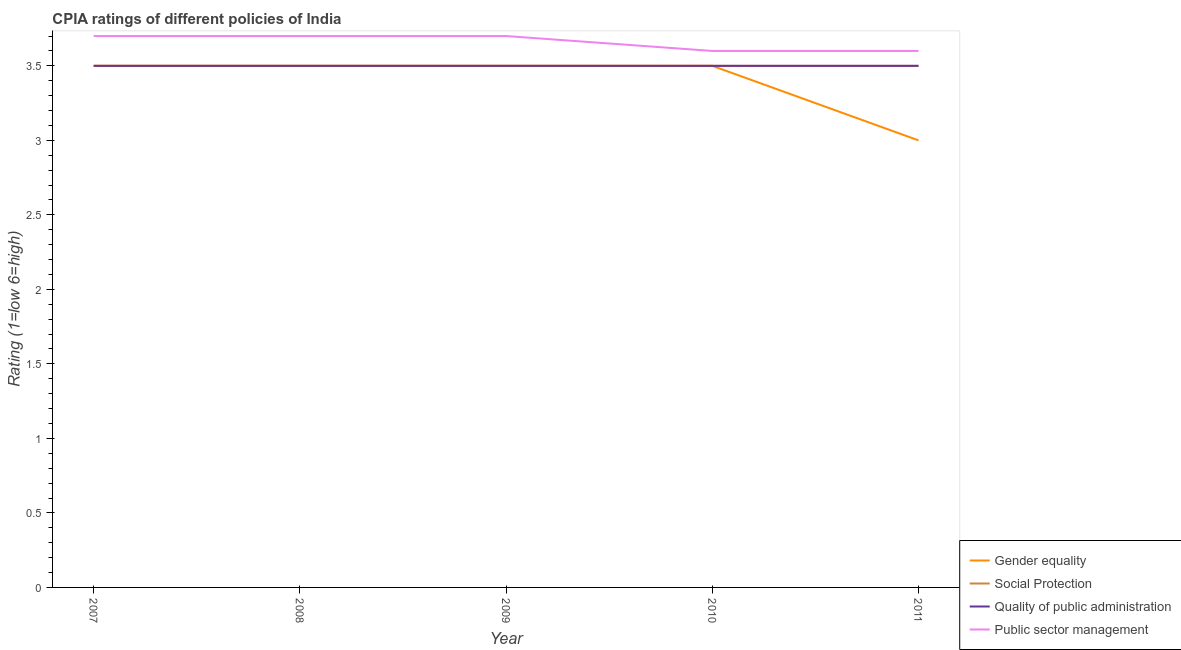Is the number of lines equal to the number of legend labels?
Keep it short and to the point. Yes. Across all years, what is the maximum cpia rating of public sector management?
Keep it short and to the point. 3.7. In which year was the cpia rating of social protection maximum?
Your answer should be very brief. 2007. What is the difference between the cpia rating of public sector management in 2007 and the cpia rating of quality of public administration in 2008?
Offer a very short reply. 0.2. In the year 2011, what is the difference between the cpia rating of gender equality and cpia rating of social protection?
Provide a succinct answer. -0.5. In how many years, is the cpia rating of quality of public administration greater than 2.2?
Your response must be concise. 5. What is the ratio of the cpia rating of quality of public administration in 2007 to that in 2011?
Your answer should be very brief. 1. What is the difference between the highest and the second highest cpia rating of public sector management?
Keep it short and to the point. 0. Does the cpia rating of gender equality monotonically increase over the years?
Make the answer very short. No. Is the cpia rating of gender equality strictly less than the cpia rating of social protection over the years?
Ensure brevity in your answer.  No. How many lines are there?
Make the answer very short. 4. How many years are there in the graph?
Make the answer very short. 5. What is the difference between two consecutive major ticks on the Y-axis?
Ensure brevity in your answer.  0.5. Does the graph contain any zero values?
Give a very brief answer. No. What is the title of the graph?
Your answer should be compact. CPIA ratings of different policies of India. What is the label or title of the Y-axis?
Your answer should be compact. Rating (1=low 6=high). What is the Rating (1=low 6=high) of Social Protection in 2007?
Keep it short and to the point. 3.5. What is the Rating (1=low 6=high) in Public sector management in 2007?
Ensure brevity in your answer.  3.7. What is the Rating (1=low 6=high) of Social Protection in 2008?
Give a very brief answer. 3.5. What is the Rating (1=low 6=high) of Quality of public administration in 2008?
Offer a very short reply. 3.5. What is the Rating (1=low 6=high) in Public sector management in 2008?
Your response must be concise. 3.7. What is the Rating (1=low 6=high) of Gender equality in 2009?
Provide a succinct answer. 3.5. What is the Rating (1=low 6=high) of Social Protection in 2009?
Your answer should be compact. 3.5. What is the Rating (1=low 6=high) in Public sector management in 2009?
Your response must be concise. 3.7. What is the Rating (1=low 6=high) of Gender equality in 2010?
Give a very brief answer. 3.5. What is the Rating (1=low 6=high) of Quality of public administration in 2010?
Offer a terse response. 3.5. What is the Rating (1=low 6=high) in Gender equality in 2011?
Keep it short and to the point. 3. What is the Rating (1=low 6=high) in Social Protection in 2011?
Offer a terse response. 3.5. What is the Rating (1=low 6=high) in Public sector management in 2011?
Ensure brevity in your answer.  3.6. Across all years, what is the maximum Rating (1=low 6=high) in Gender equality?
Offer a terse response. 3.5. Across all years, what is the maximum Rating (1=low 6=high) in Social Protection?
Your answer should be very brief. 3.5. Across all years, what is the minimum Rating (1=low 6=high) of Gender equality?
Your response must be concise. 3. What is the total Rating (1=low 6=high) of Gender equality in the graph?
Make the answer very short. 17. What is the difference between the Rating (1=low 6=high) in Social Protection in 2007 and that in 2008?
Provide a succinct answer. 0. What is the difference between the Rating (1=low 6=high) in Quality of public administration in 2007 and that in 2008?
Offer a very short reply. 0. What is the difference between the Rating (1=low 6=high) of Public sector management in 2007 and that in 2008?
Make the answer very short. 0. What is the difference between the Rating (1=low 6=high) of Gender equality in 2007 and that in 2009?
Provide a short and direct response. 0. What is the difference between the Rating (1=low 6=high) in Quality of public administration in 2007 and that in 2010?
Offer a terse response. 0. What is the difference between the Rating (1=low 6=high) of Gender equality in 2007 and that in 2011?
Provide a succinct answer. 0.5. What is the difference between the Rating (1=low 6=high) of Quality of public administration in 2007 and that in 2011?
Your response must be concise. 0. What is the difference between the Rating (1=low 6=high) in Public sector management in 2007 and that in 2011?
Your response must be concise. 0.1. What is the difference between the Rating (1=low 6=high) in Gender equality in 2008 and that in 2010?
Provide a short and direct response. 0. What is the difference between the Rating (1=low 6=high) in Gender equality in 2008 and that in 2011?
Keep it short and to the point. 0.5. What is the difference between the Rating (1=low 6=high) of Social Protection in 2008 and that in 2011?
Provide a short and direct response. 0. What is the difference between the Rating (1=low 6=high) of Quality of public administration in 2008 and that in 2011?
Provide a succinct answer. 0. What is the difference between the Rating (1=low 6=high) in Public sector management in 2008 and that in 2011?
Your response must be concise. 0.1. What is the difference between the Rating (1=low 6=high) of Quality of public administration in 2009 and that in 2010?
Your answer should be compact. 0. What is the difference between the Rating (1=low 6=high) in Social Protection in 2009 and that in 2011?
Your response must be concise. 0. What is the difference between the Rating (1=low 6=high) of Public sector management in 2009 and that in 2011?
Ensure brevity in your answer.  0.1. What is the difference between the Rating (1=low 6=high) in Quality of public administration in 2010 and that in 2011?
Keep it short and to the point. 0. What is the difference between the Rating (1=low 6=high) of Public sector management in 2010 and that in 2011?
Offer a terse response. 0. What is the difference between the Rating (1=low 6=high) of Gender equality in 2007 and the Rating (1=low 6=high) of Social Protection in 2008?
Your response must be concise. 0. What is the difference between the Rating (1=low 6=high) in Gender equality in 2007 and the Rating (1=low 6=high) in Public sector management in 2008?
Provide a short and direct response. -0.2. What is the difference between the Rating (1=low 6=high) in Social Protection in 2007 and the Rating (1=low 6=high) in Quality of public administration in 2008?
Keep it short and to the point. 0. What is the difference between the Rating (1=low 6=high) in Quality of public administration in 2007 and the Rating (1=low 6=high) in Public sector management in 2008?
Your answer should be compact. -0.2. What is the difference between the Rating (1=low 6=high) in Gender equality in 2007 and the Rating (1=low 6=high) in Quality of public administration in 2009?
Provide a succinct answer. 0. What is the difference between the Rating (1=low 6=high) of Social Protection in 2007 and the Rating (1=low 6=high) of Quality of public administration in 2009?
Your response must be concise. 0. What is the difference between the Rating (1=low 6=high) in Gender equality in 2007 and the Rating (1=low 6=high) in Quality of public administration in 2010?
Ensure brevity in your answer.  0. What is the difference between the Rating (1=low 6=high) in Social Protection in 2007 and the Rating (1=low 6=high) in Quality of public administration in 2010?
Provide a succinct answer. 0. What is the difference between the Rating (1=low 6=high) in Gender equality in 2007 and the Rating (1=low 6=high) in Quality of public administration in 2011?
Keep it short and to the point. 0. What is the difference between the Rating (1=low 6=high) in Gender equality in 2007 and the Rating (1=low 6=high) in Public sector management in 2011?
Provide a short and direct response. -0.1. What is the difference between the Rating (1=low 6=high) of Social Protection in 2007 and the Rating (1=low 6=high) of Quality of public administration in 2011?
Your response must be concise. 0. What is the difference between the Rating (1=low 6=high) of Gender equality in 2008 and the Rating (1=low 6=high) of Social Protection in 2009?
Keep it short and to the point. 0. What is the difference between the Rating (1=low 6=high) in Quality of public administration in 2008 and the Rating (1=low 6=high) in Public sector management in 2009?
Your answer should be compact. -0.2. What is the difference between the Rating (1=low 6=high) in Gender equality in 2008 and the Rating (1=low 6=high) in Social Protection in 2010?
Your answer should be very brief. 0. What is the difference between the Rating (1=low 6=high) in Gender equality in 2008 and the Rating (1=low 6=high) in Quality of public administration in 2010?
Your answer should be very brief. 0. What is the difference between the Rating (1=low 6=high) in Gender equality in 2008 and the Rating (1=low 6=high) in Public sector management in 2010?
Your answer should be very brief. -0.1. What is the difference between the Rating (1=low 6=high) of Quality of public administration in 2008 and the Rating (1=low 6=high) of Public sector management in 2010?
Your answer should be very brief. -0.1. What is the difference between the Rating (1=low 6=high) of Gender equality in 2008 and the Rating (1=low 6=high) of Quality of public administration in 2011?
Your answer should be compact. 0. What is the difference between the Rating (1=low 6=high) in Social Protection in 2008 and the Rating (1=low 6=high) in Quality of public administration in 2011?
Offer a very short reply. 0. What is the difference between the Rating (1=low 6=high) in Quality of public administration in 2008 and the Rating (1=low 6=high) in Public sector management in 2011?
Your answer should be compact. -0.1. What is the difference between the Rating (1=low 6=high) of Gender equality in 2009 and the Rating (1=low 6=high) of Social Protection in 2010?
Give a very brief answer. 0. What is the difference between the Rating (1=low 6=high) in Gender equality in 2009 and the Rating (1=low 6=high) in Quality of public administration in 2010?
Keep it short and to the point. 0. What is the difference between the Rating (1=low 6=high) of Gender equality in 2009 and the Rating (1=low 6=high) of Public sector management in 2010?
Make the answer very short. -0.1. What is the difference between the Rating (1=low 6=high) of Social Protection in 2009 and the Rating (1=low 6=high) of Quality of public administration in 2010?
Your response must be concise. 0. What is the difference between the Rating (1=low 6=high) of Quality of public administration in 2009 and the Rating (1=low 6=high) of Public sector management in 2010?
Your answer should be very brief. -0.1. What is the difference between the Rating (1=low 6=high) of Gender equality in 2009 and the Rating (1=low 6=high) of Social Protection in 2011?
Your answer should be compact. 0. What is the difference between the Rating (1=low 6=high) of Gender equality in 2009 and the Rating (1=low 6=high) of Quality of public administration in 2011?
Offer a very short reply. 0. What is the difference between the Rating (1=low 6=high) in Social Protection in 2009 and the Rating (1=low 6=high) in Quality of public administration in 2011?
Keep it short and to the point. 0. What is the difference between the Rating (1=low 6=high) in Social Protection in 2009 and the Rating (1=low 6=high) in Public sector management in 2011?
Give a very brief answer. -0.1. What is the difference between the Rating (1=low 6=high) of Quality of public administration in 2009 and the Rating (1=low 6=high) of Public sector management in 2011?
Offer a very short reply. -0.1. What is the difference between the Rating (1=low 6=high) in Gender equality in 2010 and the Rating (1=low 6=high) in Social Protection in 2011?
Your answer should be compact. 0. What is the difference between the Rating (1=low 6=high) of Gender equality in 2010 and the Rating (1=low 6=high) of Public sector management in 2011?
Keep it short and to the point. -0.1. What is the difference between the Rating (1=low 6=high) in Social Protection in 2010 and the Rating (1=low 6=high) in Public sector management in 2011?
Keep it short and to the point. -0.1. What is the difference between the Rating (1=low 6=high) in Quality of public administration in 2010 and the Rating (1=low 6=high) in Public sector management in 2011?
Provide a succinct answer. -0.1. What is the average Rating (1=low 6=high) in Public sector management per year?
Keep it short and to the point. 3.66. In the year 2007, what is the difference between the Rating (1=low 6=high) in Gender equality and Rating (1=low 6=high) in Social Protection?
Ensure brevity in your answer.  0. In the year 2007, what is the difference between the Rating (1=low 6=high) of Social Protection and Rating (1=low 6=high) of Public sector management?
Give a very brief answer. -0.2. In the year 2007, what is the difference between the Rating (1=low 6=high) in Quality of public administration and Rating (1=low 6=high) in Public sector management?
Keep it short and to the point. -0.2. In the year 2008, what is the difference between the Rating (1=low 6=high) of Gender equality and Rating (1=low 6=high) of Public sector management?
Give a very brief answer. -0.2. In the year 2009, what is the difference between the Rating (1=low 6=high) of Gender equality and Rating (1=low 6=high) of Social Protection?
Your answer should be very brief. 0. In the year 2009, what is the difference between the Rating (1=low 6=high) in Gender equality and Rating (1=low 6=high) in Public sector management?
Provide a succinct answer. -0.2. In the year 2009, what is the difference between the Rating (1=low 6=high) of Social Protection and Rating (1=low 6=high) of Quality of public administration?
Offer a very short reply. 0. In the year 2009, what is the difference between the Rating (1=low 6=high) of Social Protection and Rating (1=low 6=high) of Public sector management?
Provide a short and direct response. -0.2. In the year 2009, what is the difference between the Rating (1=low 6=high) of Quality of public administration and Rating (1=low 6=high) of Public sector management?
Make the answer very short. -0.2. In the year 2010, what is the difference between the Rating (1=low 6=high) of Social Protection and Rating (1=low 6=high) of Public sector management?
Offer a very short reply. -0.1. In the year 2010, what is the difference between the Rating (1=low 6=high) in Quality of public administration and Rating (1=low 6=high) in Public sector management?
Ensure brevity in your answer.  -0.1. In the year 2011, what is the difference between the Rating (1=low 6=high) of Gender equality and Rating (1=low 6=high) of Social Protection?
Offer a terse response. -0.5. In the year 2011, what is the difference between the Rating (1=low 6=high) in Gender equality and Rating (1=low 6=high) in Quality of public administration?
Make the answer very short. -0.5. In the year 2011, what is the difference between the Rating (1=low 6=high) in Gender equality and Rating (1=low 6=high) in Public sector management?
Your response must be concise. -0.6. In the year 2011, what is the difference between the Rating (1=low 6=high) of Quality of public administration and Rating (1=low 6=high) of Public sector management?
Offer a terse response. -0.1. What is the ratio of the Rating (1=low 6=high) in Gender equality in 2007 to that in 2008?
Ensure brevity in your answer.  1. What is the ratio of the Rating (1=low 6=high) of Social Protection in 2007 to that in 2008?
Your answer should be very brief. 1. What is the ratio of the Rating (1=low 6=high) of Quality of public administration in 2007 to that in 2008?
Your answer should be compact. 1. What is the ratio of the Rating (1=low 6=high) of Public sector management in 2007 to that in 2008?
Keep it short and to the point. 1. What is the ratio of the Rating (1=low 6=high) in Gender equality in 2007 to that in 2010?
Give a very brief answer. 1. What is the ratio of the Rating (1=low 6=high) in Quality of public administration in 2007 to that in 2010?
Your answer should be very brief. 1. What is the ratio of the Rating (1=low 6=high) of Public sector management in 2007 to that in 2010?
Provide a short and direct response. 1.03. What is the ratio of the Rating (1=low 6=high) in Gender equality in 2007 to that in 2011?
Offer a terse response. 1.17. What is the ratio of the Rating (1=low 6=high) of Public sector management in 2007 to that in 2011?
Your response must be concise. 1.03. What is the ratio of the Rating (1=low 6=high) in Gender equality in 2008 to that in 2009?
Your answer should be compact. 1. What is the ratio of the Rating (1=low 6=high) in Social Protection in 2008 to that in 2009?
Offer a very short reply. 1. What is the ratio of the Rating (1=low 6=high) of Public sector management in 2008 to that in 2009?
Provide a succinct answer. 1. What is the ratio of the Rating (1=low 6=high) of Public sector management in 2008 to that in 2010?
Make the answer very short. 1.03. What is the ratio of the Rating (1=low 6=high) of Social Protection in 2008 to that in 2011?
Provide a short and direct response. 1. What is the ratio of the Rating (1=low 6=high) in Quality of public administration in 2008 to that in 2011?
Keep it short and to the point. 1. What is the ratio of the Rating (1=low 6=high) in Public sector management in 2008 to that in 2011?
Your answer should be compact. 1.03. What is the ratio of the Rating (1=low 6=high) of Gender equality in 2009 to that in 2010?
Make the answer very short. 1. What is the ratio of the Rating (1=low 6=high) of Social Protection in 2009 to that in 2010?
Offer a terse response. 1. What is the ratio of the Rating (1=low 6=high) in Quality of public administration in 2009 to that in 2010?
Provide a succinct answer. 1. What is the ratio of the Rating (1=low 6=high) of Public sector management in 2009 to that in 2010?
Provide a short and direct response. 1.03. What is the ratio of the Rating (1=low 6=high) of Gender equality in 2009 to that in 2011?
Provide a succinct answer. 1.17. What is the ratio of the Rating (1=low 6=high) of Public sector management in 2009 to that in 2011?
Provide a short and direct response. 1.03. What is the ratio of the Rating (1=low 6=high) in Gender equality in 2010 to that in 2011?
Your answer should be compact. 1.17. What is the difference between the highest and the second highest Rating (1=low 6=high) in Social Protection?
Your answer should be compact. 0. What is the difference between the highest and the second highest Rating (1=low 6=high) of Quality of public administration?
Your response must be concise. 0. What is the difference between the highest and the second highest Rating (1=low 6=high) in Public sector management?
Keep it short and to the point. 0. What is the difference between the highest and the lowest Rating (1=low 6=high) in Gender equality?
Your answer should be compact. 0.5. What is the difference between the highest and the lowest Rating (1=low 6=high) of Quality of public administration?
Your answer should be compact. 0. 